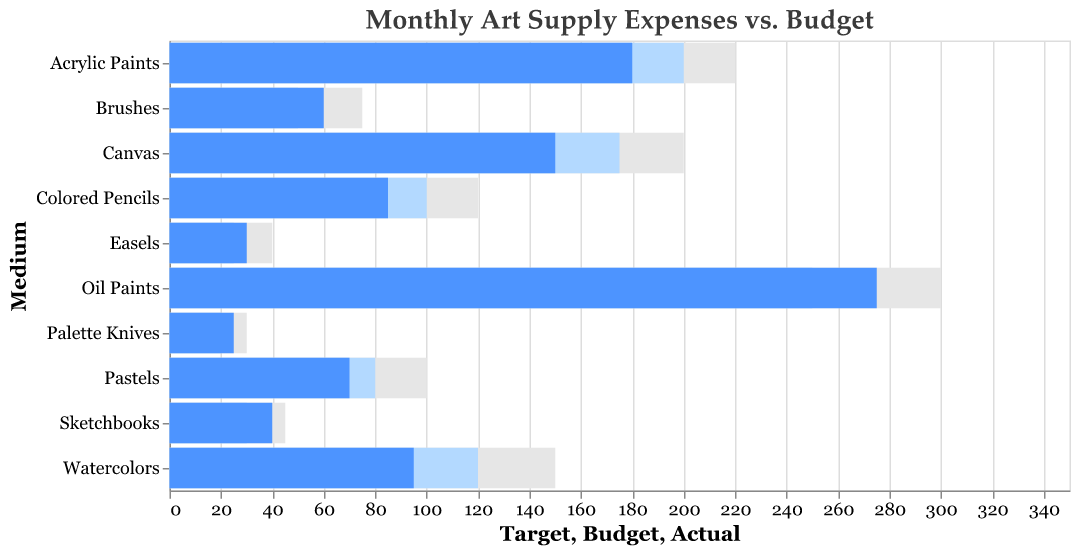What’s the title of the chart? The title can be found at the top of the figure and it states what the chart represents. It is typically set in a larger font size to make it stand out.
Answer: Monthly Art Supply Expenses vs. Budget How many mediums are represented in the chart? The number of mediums can be counted by looking at the y-axis where each medium is listed.
Answer: 10 Which medium had the highest actual expenses? By comparing the Actual expenses bars, you can see which one extends the furthest to the right.
Answer: Oil Paints How did the actual expenses for Watercolors compare to the budgeted amount? Find the bars for Watercolors and compare the length of the Actual bar to the Budget bar.
Answer: Actual expenses were less than the budget Among Brushes, Sketchbooks, and Palette Knives, which had the highest actual expenses? Compare the Actual expenses bars for Brushes, Sketchbooks, and Palette Knives.
Answer: Brushes What was the difference between the budget and actual expenses for Oil Paints? Look at the values labeled Budget and Actual for Oil Paints and subtract the Budget from the Actual (275 - 250).
Answer: 25 Which medium had the smallest difference between its target and actual expenses? Calculate the absolute difference between Target and Actual for each medium and find the smallest one. Detailed calculations show that Palette Knives had the difference of 5.
Answer: Palette Knives What is the average budget across all mediums? Sum all the budget values and divide by the number of mediums (250 + 200 + 120 + 175 + 50 + 30 + 100 + 80 + 25 + 20 = 1050; 1050 / 10).
Answer: 105 Which medium most significantly exceeded its target expenses? Calculate the difference (if positive) between Actual and Target for each medium and compare them. Oil Paints exceeded the target of 300 by -25, which is the greatest deficit.
Answer: None How does the budget for Canvas compare to the budget for Colored Pencils? Compare the heights of the Budget bars for Canvas and Colored Pencils directly.
Answer: Canvas is higher by 75 